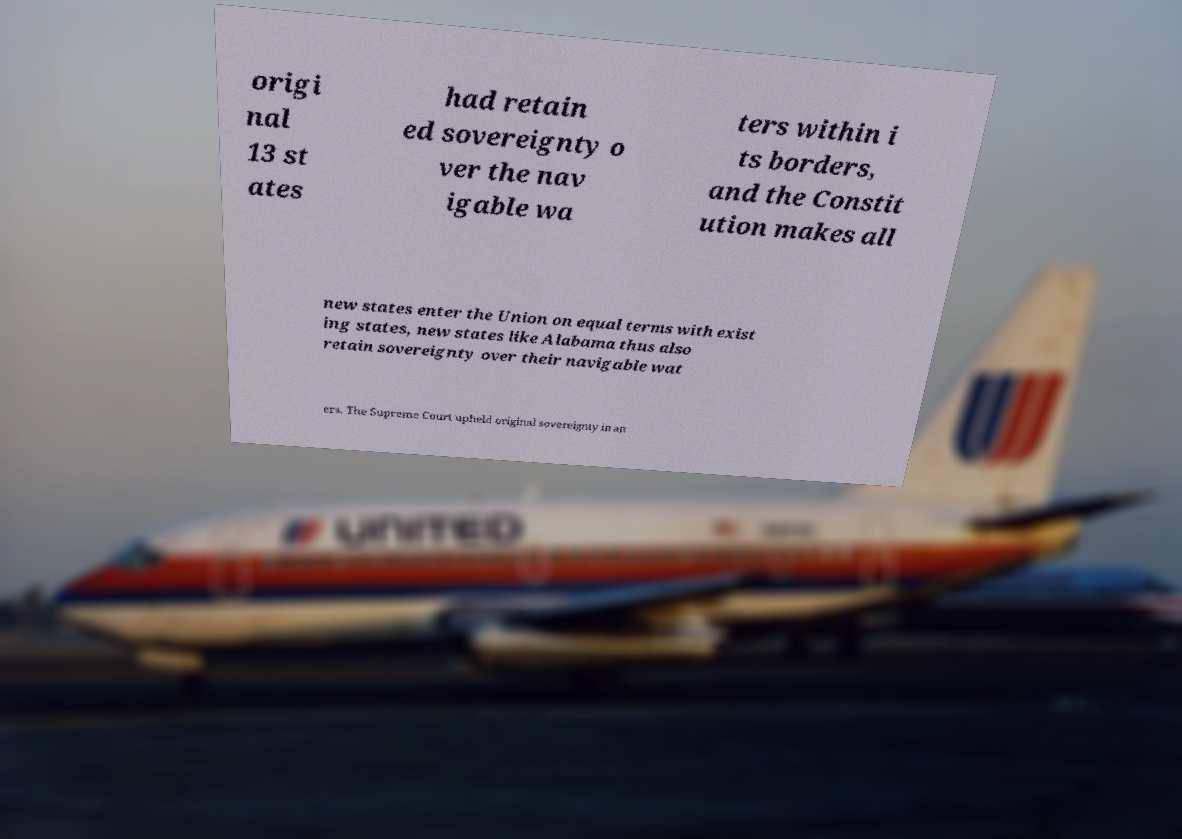Could you extract and type out the text from this image? origi nal 13 st ates had retain ed sovereignty o ver the nav igable wa ters within i ts borders, and the Constit ution makes all new states enter the Union on equal terms with exist ing states, new states like Alabama thus also retain sovereignty over their navigable wat ers. The Supreme Court upheld original sovereignty in an 